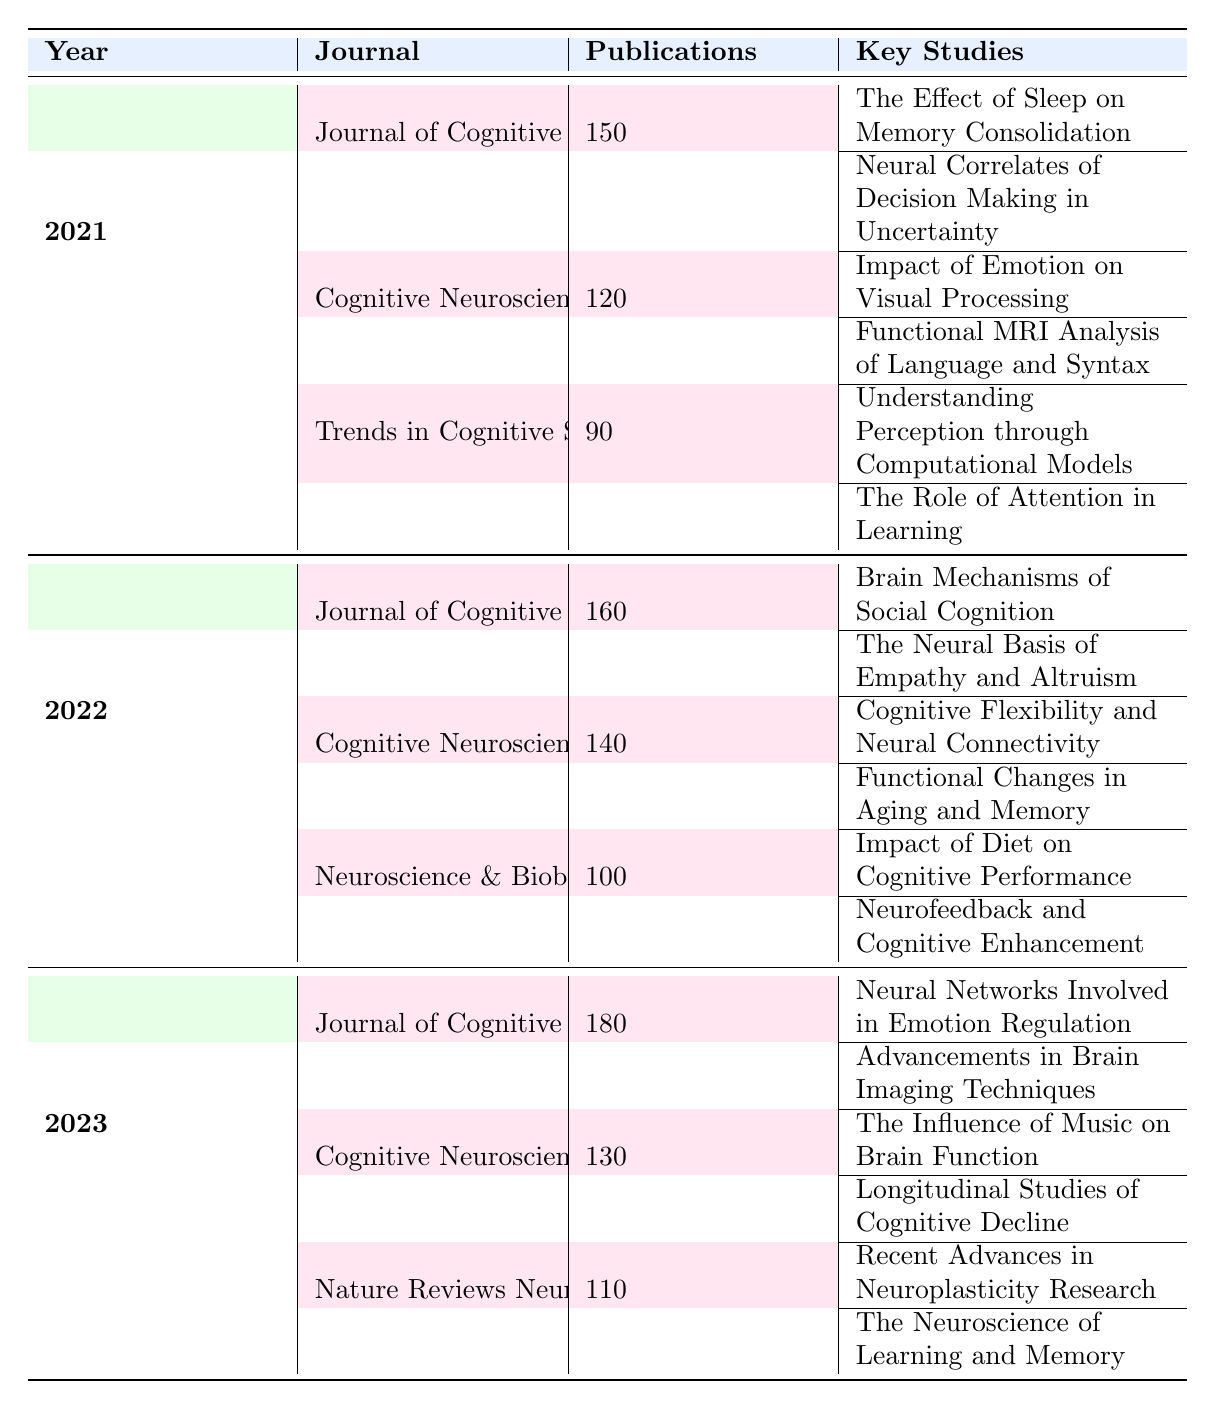What was the total number of publications in 2021? For the year 2021, the publications are as follows: Journal of Cognitive Neuroscience (150), Cognitive Neuroscience (120), and Trends in Cognitive Sciences (90). Summing these values gives 150 + 120 + 90 = 360.
Answer: 360 Which journal had the highest number of publications in 2022? In 2022, the Journal of Cognitive Neuroscience had 160 publications, Cognitive Neuroscience had 140, and Neuroscience & Biobehavioral Reviews had 100. The highest value is 160 from the Journal of Cognitive Neuroscience.
Answer: Journal of Cognitive Neuroscience Did the number of publications in the Journal of Cognitive Neuroscience increase from 2021 to 2023? The Journal of Cognitive Neuroscience had 150 publications in 2021 and increased to 180 in 2023. Since 180 is greater than 150, the number of publications did increase.
Answer: Yes What is the average number of publications in 2023 across all three journals? In 2023, the publications are as follows: Journal of Cognitive Neuroscience (180), Cognitive Neuroscience (130), and Nature Reviews Neuroscience (110). To find the average, first sum these values: 180 + 130 + 110 = 420. Then divide by the number of journals (3), giving 420 / 3 = 140.
Answer: 140 Which year saw the lowest total number of publications across all journals? For each year, the total number of publications is: 2021: 360 (150 + 120 + 90), 2022: 400 (160 + 140 + 100), and 2023: 420 (180 + 130 + 110). The lowest total is from 2021, which had 360.
Answer: 2021 